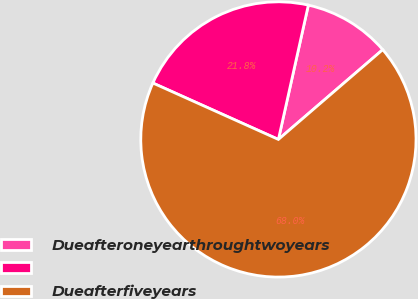Convert chart to OTSL. <chart><loc_0><loc_0><loc_500><loc_500><pie_chart><fcel>Dueafteroneyearthroughtwoyears<fcel>Unnamed: 1<fcel>Dueafterfiveyears<nl><fcel>10.2%<fcel>21.77%<fcel>68.04%<nl></chart> 